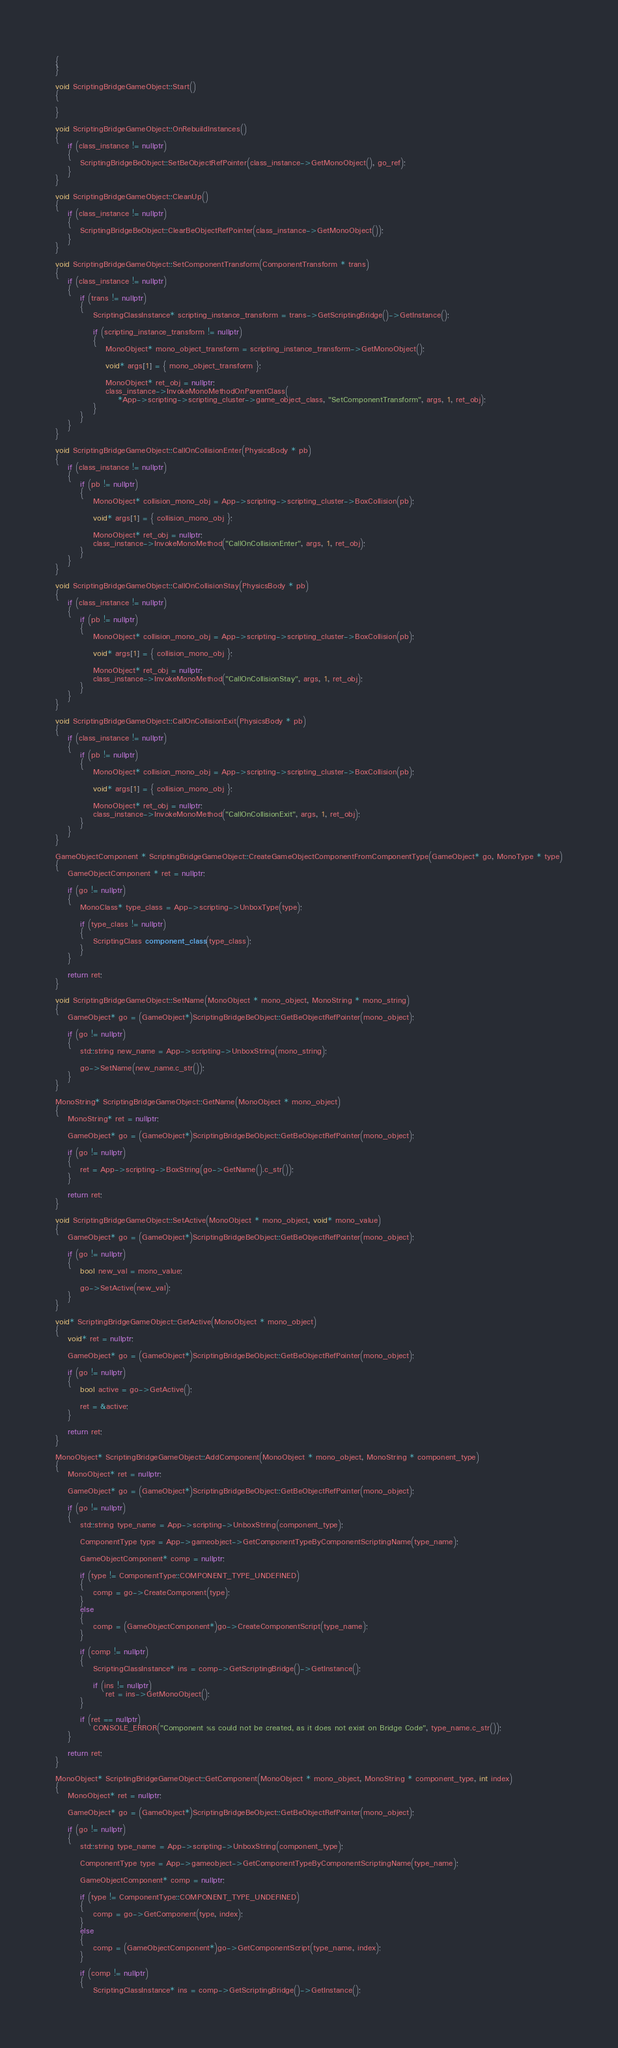Convert code to text. <code><loc_0><loc_0><loc_500><loc_500><_C++_>{
}

void ScriptingBridgeGameObject::Start()
{
	
}

void ScriptingBridgeGameObject::OnRebuildInstances()
{
	if (class_instance != nullptr)
	{
		ScriptingBridgeBeObject::SetBeObjectRefPointer(class_instance->GetMonoObject(), go_ref);
	}
}

void ScriptingBridgeGameObject::CleanUp()
{
	if (class_instance != nullptr)
	{
		ScriptingBridgeBeObject::ClearBeObjectRefPointer(class_instance->GetMonoObject());
	}
}

void ScriptingBridgeGameObject::SetComponentTransform(ComponentTransform * trans)
{
	if (class_instance != nullptr)
	{
		if (trans != nullptr)
		{
			ScriptingClassInstance* scripting_instance_transform = trans->GetScriptingBridge()->GetInstance();

			if (scripting_instance_transform != nullptr)
			{
				MonoObject* mono_object_transform = scripting_instance_transform->GetMonoObject();

				void* args[1] = { mono_object_transform };

				MonoObject* ret_obj = nullptr;
				class_instance->InvokeMonoMethodOnParentClass(
					*App->scripting->scripting_cluster->game_object_class, "SetComponentTransform", args, 1, ret_obj);
			}
		}
	}
}

void ScriptingBridgeGameObject::CallOnCollisionEnter(PhysicsBody * pb)
{
	if (class_instance != nullptr)
	{
		if (pb != nullptr)
		{
			MonoObject* collision_mono_obj = App->scripting->scripting_cluster->BoxCollision(pb);

			void* args[1] = { collision_mono_obj };

			MonoObject* ret_obj = nullptr;
			class_instance->InvokeMonoMethod("CallOnCollisionEnter", args, 1, ret_obj);
		}
	}
}

void ScriptingBridgeGameObject::CallOnCollisionStay(PhysicsBody * pb)
{
	if (class_instance != nullptr)
	{
		if (pb != nullptr)
		{
			MonoObject* collision_mono_obj = App->scripting->scripting_cluster->BoxCollision(pb);

			void* args[1] = { collision_mono_obj };

			MonoObject* ret_obj = nullptr;
			class_instance->InvokeMonoMethod("CallOnCollisionStay", args, 1, ret_obj);
		}
	}
}

void ScriptingBridgeGameObject::CallOnCollisionExit(PhysicsBody * pb)
{
	if (class_instance != nullptr)
	{
		if (pb != nullptr)
		{
			MonoObject* collision_mono_obj = App->scripting->scripting_cluster->BoxCollision(pb);

			void* args[1] = { collision_mono_obj };

			MonoObject* ret_obj = nullptr;
			class_instance->InvokeMonoMethod("CallOnCollisionExit", args, 1, ret_obj);
		}
	}
}

GameObjectComponent * ScriptingBridgeGameObject::CreateGameObjectComponentFromComponentType(GameObject* go, MonoType * type)
{
	GameObjectComponent * ret = nullptr;

	if (go != nullptr)
	{
		MonoClass* type_class = App->scripting->UnboxType(type);

		if (type_class != nullptr)
		{
			ScriptingClass component_class(type_class);
		}
	}

	return ret;
}

void ScriptingBridgeGameObject::SetName(MonoObject * mono_object, MonoString * mono_string)
{
	GameObject* go = (GameObject*)ScriptingBridgeBeObject::GetBeObjectRefPointer(mono_object);

	if (go != nullptr)
	{
		std::string new_name = App->scripting->UnboxString(mono_string);

		go->SetName(new_name.c_str());
	}
}

MonoString* ScriptingBridgeGameObject::GetName(MonoObject * mono_object)
{
	MonoString* ret = nullptr;

	GameObject* go = (GameObject*)ScriptingBridgeBeObject::GetBeObjectRefPointer(mono_object);

	if (go != nullptr)
	{
		ret = App->scripting->BoxString(go->GetName().c_str());
	}

	return ret;
}

void ScriptingBridgeGameObject::SetActive(MonoObject * mono_object, void* mono_value)
{
	GameObject* go = (GameObject*)ScriptingBridgeBeObject::GetBeObjectRefPointer(mono_object);

	if (go != nullptr)
	{
		bool new_val = mono_value;

		go->SetActive(new_val);
	}
}

void* ScriptingBridgeGameObject::GetActive(MonoObject * mono_object)
{
	void* ret = nullptr;

	GameObject* go = (GameObject*)ScriptingBridgeBeObject::GetBeObjectRefPointer(mono_object);

	if (go != nullptr)
	{
		bool active = go->GetActive();

		ret = &active;
	}

	return ret;
}

MonoObject* ScriptingBridgeGameObject::AddComponent(MonoObject * mono_object, MonoString * component_type)
{
	MonoObject* ret = nullptr;

	GameObject* go = (GameObject*)ScriptingBridgeBeObject::GetBeObjectRefPointer(mono_object);

	if (go != nullptr)
	{
		std::string type_name = App->scripting->UnboxString(component_type);

		ComponentType type = App->gameobject->GetComponentTypeByComponentScriptingName(type_name);
		
		GameObjectComponent* comp = nullptr;

		if (type != ComponentType::COMPONENT_TYPE_UNDEFINED)
		{
			comp = go->CreateComponent(type);
		}
		else
		{
			comp = (GameObjectComponent*)go->CreateComponentScript(type_name);
		}

		if (comp != nullptr)
		{
			ScriptingClassInstance* ins = comp->GetScriptingBridge()->GetInstance();

			if (ins != nullptr)
				ret = ins->GetMonoObject();
		}

		if (ret == nullptr)
			CONSOLE_ERROR("Component %s could not be created, as it does not exist on Bridge Code", type_name.c_str());
	}

	return ret;
}

MonoObject* ScriptingBridgeGameObject::GetComponent(MonoObject * mono_object, MonoString * component_type, int index)
{
	MonoObject* ret = nullptr;

	GameObject* go = (GameObject*)ScriptingBridgeBeObject::GetBeObjectRefPointer(mono_object);

	if (go != nullptr)
	{
		std::string type_name = App->scripting->UnboxString(component_type);

		ComponentType type = App->gameobject->GetComponentTypeByComponentScriptingName(type_name);

		GameObjectComponent* comp = nullptr;
		
		if (type != ComponentType::COMPONENT_TYPE_UNDEFINED)
		{
			comp = go->GetComponent(type, index);
		}
		else
		{
			comp = (GameObjectComponent*)go->GetComponentScript(type_name, index);
		}
		
		if (comp != nullptr)
		{
			ScriptingClassInstance* ins = comp->GetScriptingBridge()->GetInstance();
</code> 